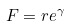<formula> <loc_0><loc_0><loc_500><loc_500>F = r e ^ { \gamma }</formula> 